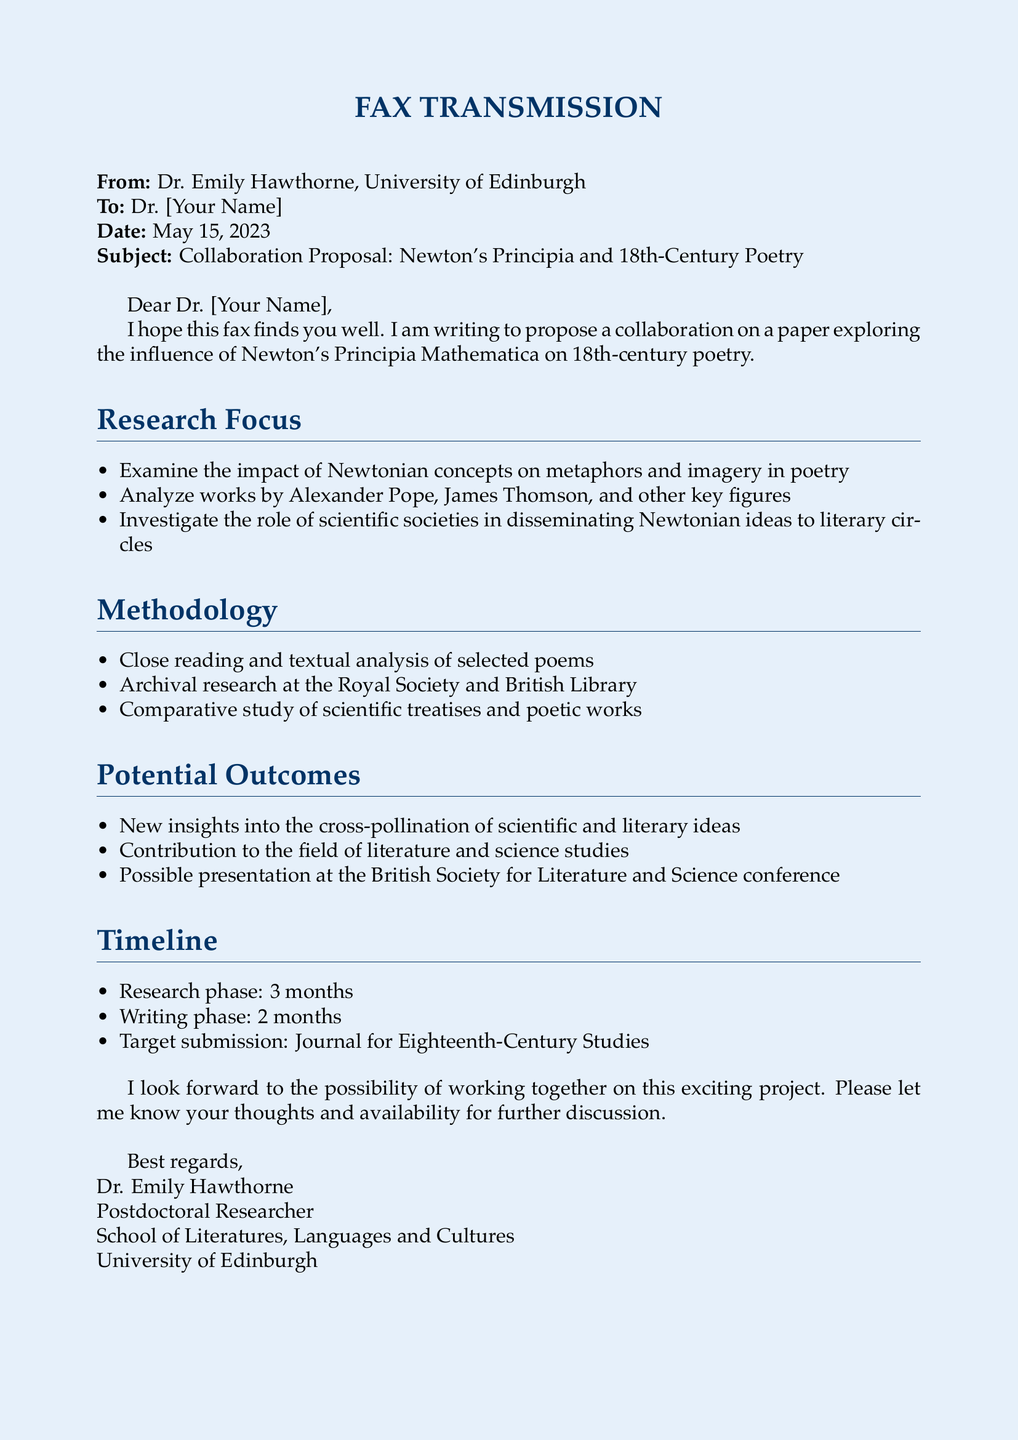What is the subject of the fax? The subject line indicates the main topic of discussion in the fax, which is a collaboration proposal focusing on Newton's Principia and its influence on poetry.
Answer: Collaboration Proposal: Newton's Principia and 18th-Century Poetry Who is the sender of the fax? The sender's name and affiliation are mentioned at the top of the fax.
Answer: Dr. Emily Hawthorne What is the target journal for submission? The document specifies the intended journal for the paper submission at the end of the timeline section.
Answer: Journal for Eighteenth-Century Studies How long is the research phase expected to last? The timeline section outlines the duration of different phases of the project, including the research phase.
Answer: 3 months Which poets are specifically mentioned for analysis in the research focus? The research focus lists key figures in poetry that will be examined, providing names relevant to the study.
Answer: Alexander Pope, James Thomson What type of research is involved at the Royal Society? The methodology section indicates the type of research that will be conducted at the Royal Society, which is primarily archival in nature.
Answer: Archival research What is one potential outcome of this collaboration? The potential outcomes section mentions various contributions to the field, one of which can be highlighted.
Answer: New insights into the cross-pollination of scientific and literary ideas What is the main focus of the proposed paper? The research focus clearly states the central theme of the proposed paper concerning Newtonian concepts and poetry.
Answer: Influence of Newton's Principia on 18th-century poetry 